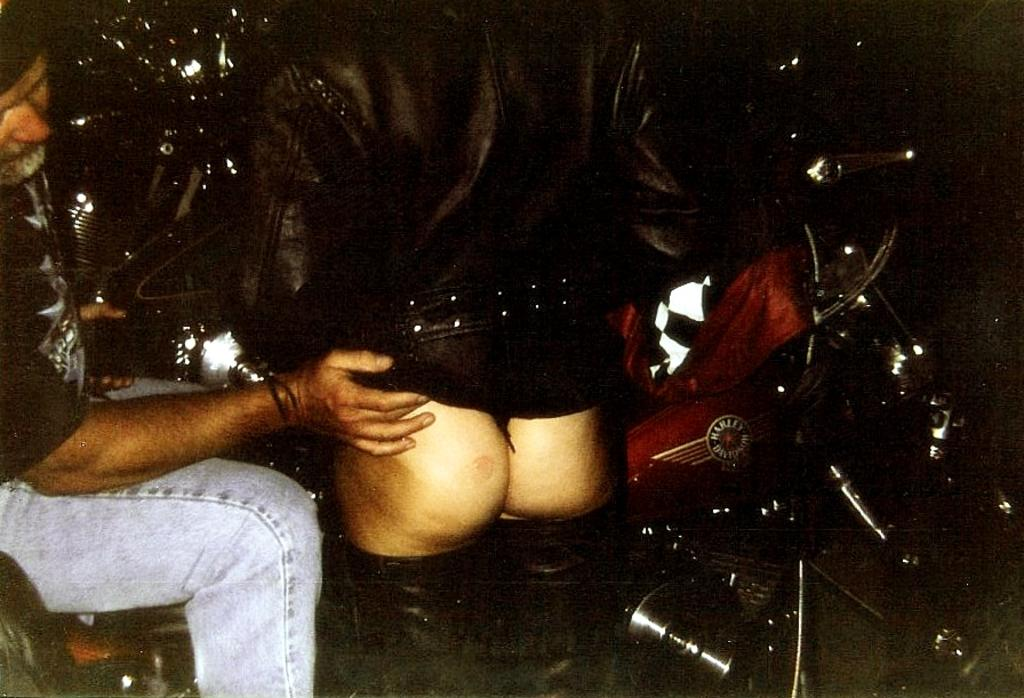Who is the main subject in the image? There is a man in the image. What is the man doing in the image? The man is sitting on a bike. Can you describe the man's interaction with the person beside him? The man is putting his hand on the person beside him. What is the rhythm of the time distribution in the image? There is no reference to time or rhythm in the image, as it features a man sitting on a bike and interacting with the person beside him. 